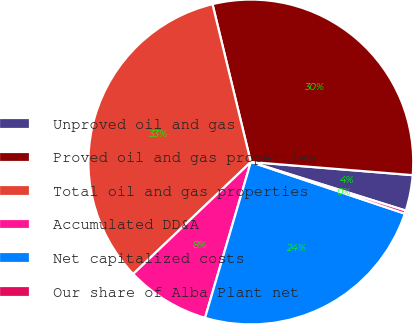Convert chart to OTSL. <chart><loc_0><loc_0><loc_500><loc_500><pie_chart><fcel>Unproved oil and gas<fcel>Proved oil and gas properties<fcel>Total oil and gas properties<fcel>Accumulated DD&A<fcel>Net capitalized costs<fcel>Our share of Alba Plant net<nl><fcel>3.55%<fcel>30.08%<fcel>33.32%<fcel>8.34%<fcel>24.4%<fcel>0.31%<nl></chart> 